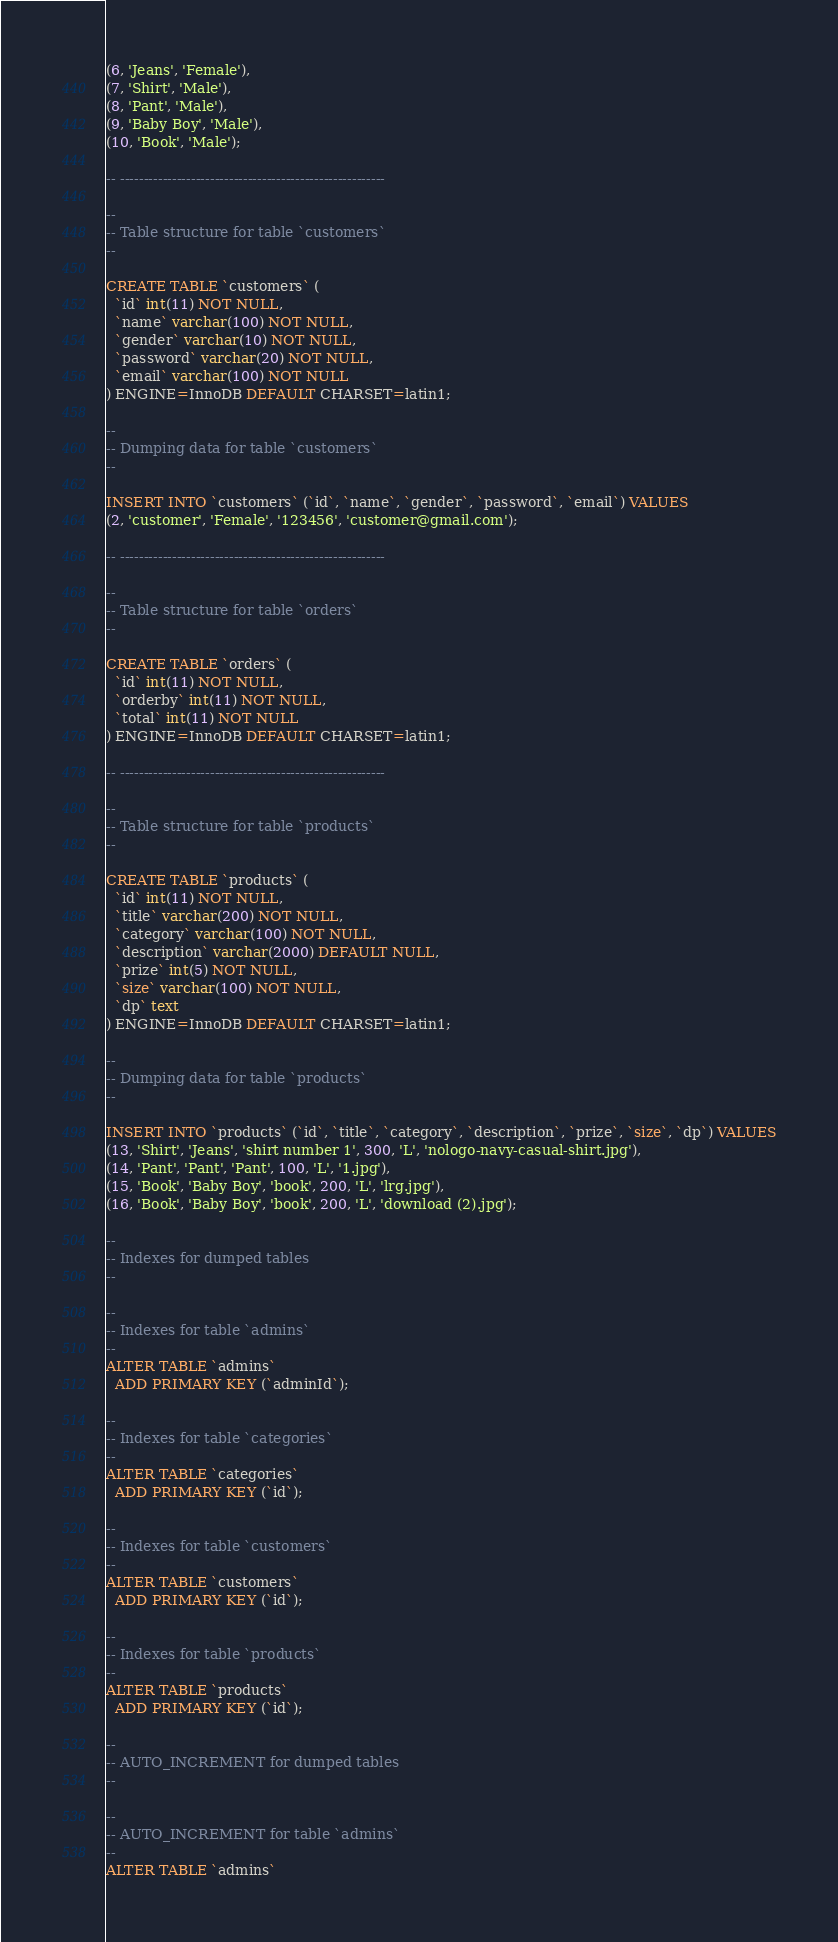<code> <loc_0><loc_0><loc_500><loc_500><_SQL_>(6, 'Jeans', 'Female'),
(7, 'Shirt', 'Male'),
(8, 'Pant', 'Male'),
(9, 'Baby Boy', 'Male'),
(10, 'Book', 'Male');

-- --------------------------------------------------------

--
-- Table structure for table `customers`
--

CREATE TABLE `customers` (
  `id` int(11) NOT NULL,
  `name` varchar(100) NOT NULL,
  `gender` varchar(10) NOT NULL,
  `password` varchar(20) NOT NULL,
  `email` varchar(100) NOT NULL
) ENGINE=InnoDB DEFAULT CHARSET=latin1;

--
-- Dumping data for table `customers`
--

INSERT INTO `customers` (`id`, `name`, `gender`, `password`, `email`) VALUES
(2, 'customer', 'Female', '123456', 'customer@gmail.com');

-- --------------------------------------------------------

--
-- Table structure for table `orders`
--

CREATE TABLE `orders` (
  `id` int(11) NOT NULL,
  `orderby` int(11) NOT NULL,
  `total` int(11) NOT NULL
) ENGINE=InnoDB DEFAULT CHARSET=latin1;

-- --------------------------------------------------------

--
-- Table structure for table `products`
--

CREATE TABLE `products` (
  `id` int(11) NOT NULL,
  `title` varchar(200) NOT NULL,
  `category` varchar(100) NOT NULL,
  `description` varchar(2000) DEFAULT NULL,
  `prize` int(5) NOT NULL,
  `size` varchar(100) NOT NULL,
  `dp` text
) ENGINE=InnoDB DEFAULT CHARSET=latin1;

--
-- Dumping data for table `products`
--

INSERT INTO `products` (`id`, `title`, `category`, `description`, `prize`, `size`, `dp`) VALUES
(13, 'Shirt', 'Jeans', 'shirt number 1', 300, 'L', 'nologo-navy-casual-shirt.jpg'),
(14, 'Pant', 'Pant', 'Pant', 100, 'L', '1.jpg'),
(15, 'Book', 'Baby Boy', 'book', 200, 'L', 'lrg.jpg'),
(16, 'Book', 'Baby Boy', 'book', 200, 'L', 'download (2).jpg');

--
-- Indexes for dumped tables
--

--
-- Indexes for table `admins`
--
ALTER TABLE `admins`
  ADD PRIMARY KEY (`adminId`);

--
-- Indexes for table `categories`
--
ALTER TABLE `categories`
  ADD PRIMARY KEY (`id`);

--
-- Indexes for table `customers`
--
ALTER TABLE `customers`
  ADD PRIMARY KEY (`id`);

--
-- Indexes for table `products`
--
ALTER TABLE `products`
  ADD PRIMARY KEY (`id`);

--
-- AUTO_INCREMENT for dumped tables
--

--
-- AUTO_INCREMENT for table `admins`
--
ALTER TABLE `admins`</code> 